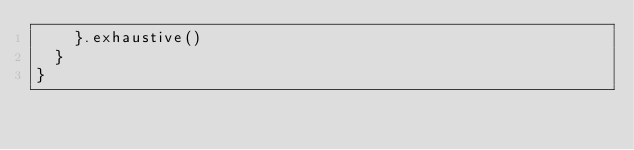<code> <loc_0><loc_0><loc_500><loc_500><_Kotlin_>    }.exhaustive()
  }
}
</code> 